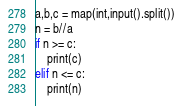<code> <loc_0><loc_0><loc_500><loc_500><_Python_>a,b,c = map(int,input().split())
n = b//a
if n >= c:
    print(c)
elif n <= c:
    print(n)
</code> 